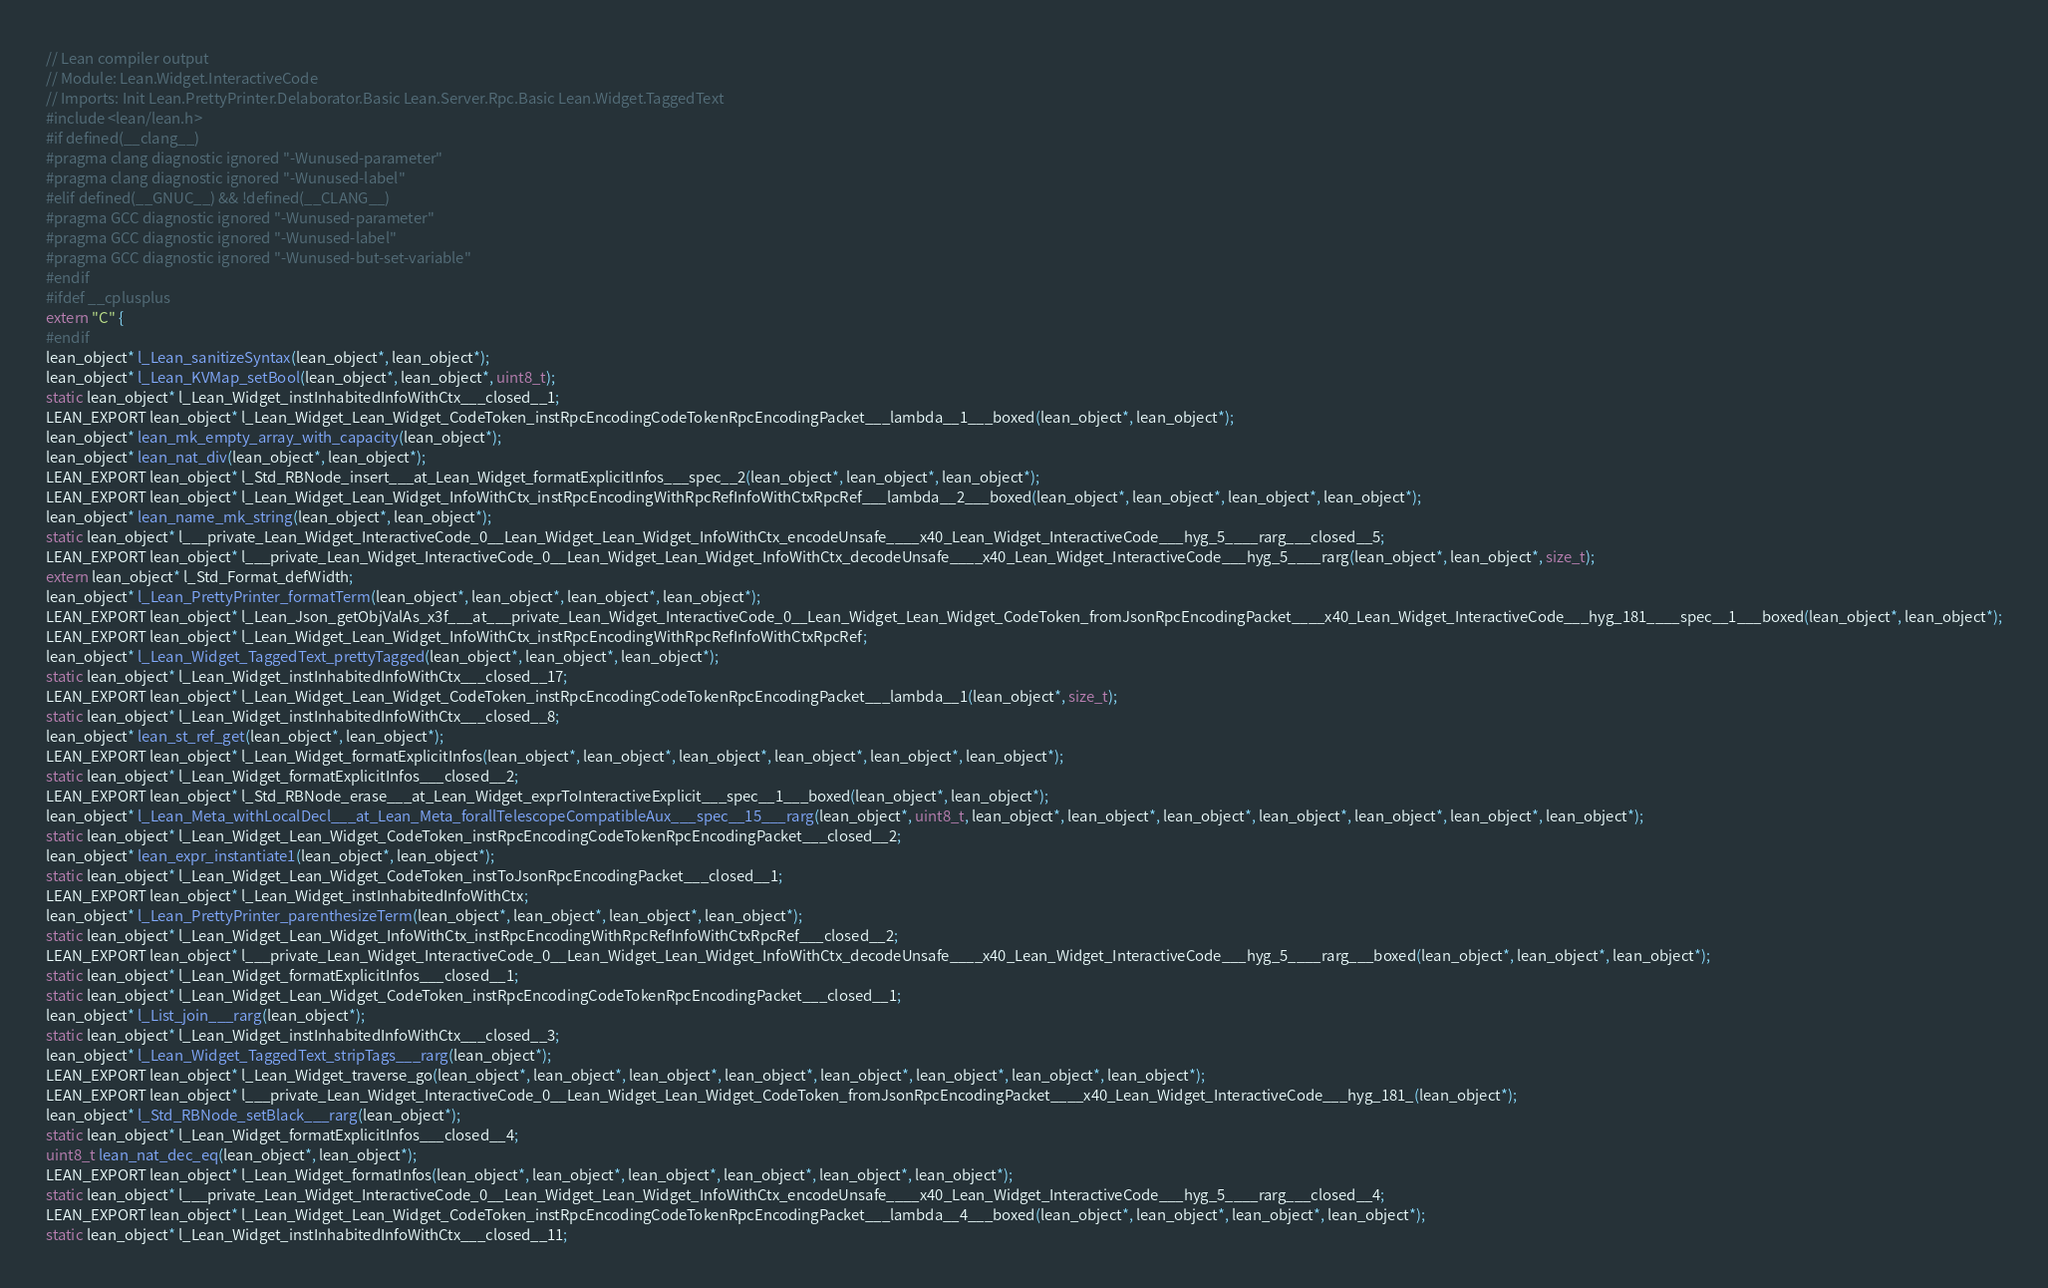Convert code to text. <code><loc_0><loc_0><loc_500><loc_500><_C_>// Lean compiler output
// Module: Lean.Widget.InteractiveCode
// Imports: Init Lean.PrettyPrinter.Delaborator.Basic Lean.Server.Rpc.Basic Lean.Widget.TaggedText
#include <lean/lean.h>
#if defined(__clang__)
#pragma clang diagnostic ignored "-Wunused-parameter"
#pragma clang diagnostic ignored "-Wunused-label"
#elif defined(__GNUC__) && !defined(__CLANG__)
#pragma GCC diagnostic ignored "-Wunused-parameter"
#pragma GCC diagnostic ignored "-Wunused-label"
#pragma GCC diagnostic ignored "-Wunused-but-set-variable"
#endif
#ifdef __cplusplus
extern "C" {
#endif
lean_object* l_Lean_sanitizeSyntax(lean_object*, lean_object*);
lean_object* l_Lean_KVMap_setBool(lean_object*, lean_object*, uint8_t);
static lean_object* l_Lean_Widget_instInhabitedInfoWithCtx___closed__1;
LEAN_EXPORT lean_object* l_Lean_Widget_Lean_Widget_CodeToken_instRpcEncodingCodeTokenRpcEncodingPacket___lambda__1___boxed(lean_object*, lean_object*);
lean_object* lean_mk_empty_array_with_capacity(lean_object*);
lean_object* lean_nat_div(lean_object*, lean_object*);
LEAN_EXPORT lean_object* l_Std_RBNode_insert___at_Lean_Widget_formatExplicitInfos___spec__2(lean_object*, lean_object*, lean_object*);
LEAN_EXPORT lean_object* l_Lean_Widget_Lean_Widget_InfoWithCtx_instRpcEncodingWithRpcRefInfoWithCtxRpcRef___lambda__2___boxed(lean_object*, lean_object*, lean_object*, lean_object*);
lean_object* lean_name_mk_string(lean_object*, lean_object*);
static lean_object* l___private_Lean_Widget_InteractiveCode_0__Lean_Widget_Lean_Widget_InfoWithCtx_encodeUnsafe____x40_Lean_Widget_InteractiveCode___hyg_5____rarg___closed__5;
LEAN_EXPORT lean_object* l___private_Lean_Widget_InteractiveCode_0__Lean_Widget_Lean_Widget_InfoWithCtx_decodeUnsafe____x40_Lean_Widget_InteractiveCode___hyg_5____rarg(lean_object*, lean_object*, size_t);
extern lean_object* l_Std_Format_defWidth;
lean_object* l_Lean_PrettyPrinter_formatTerm(lean_object*, lean_object*, lean_object*, lean_object*);
LEAN_EXPORT lean_object* l_Lean_Json_getObjValAs_x3f___at___private_Lean_Widget_InteractiveCode_0__Lean_Widget_Lean_Widget_CodeToken_fromJsonRpcEncodingPacket____x40_Lean_Widget_InteractiveCode___hyg_181____spec__1___boxed(lean_object*, lean_object*);
LEAN_EXPORT lean_object* l_Lean_Widget_Lean_Widget_InfoWithCtx_instRpcEncodingWithRpcRefInfoWithCtxRpcRef;
lean_object* l_Lean_Widget_TaggedText_prettyTagged(lean_object*, lean_object*, lean_object*);
static lean_object* l_Lean_Widget_instInhabitedInfoWithCtx___closed__17;
LEAN_EXPORT lean_object* l_Lean_Widget_Lean_Widget_CodeToken_instRpcEncodingCodeTokenRpcEncodingPacket___lambda__1(lean_object*, size_t);
static lean_object* l_Lean_Widget_instInhabitedInfoWithCtx___closed__8;
lean_object* lean_st_ref_get(lean_object*, lean_object*);
LEAN_EXPORT lean_object* l_Lean_Widget_formatExplicitInfos(lean_object*, lean_object*, lean_object*, lean_object*, lean_object*, lean_object*);
static lean_object* l_Lean_Widget_formatExplicitInfos___closed__2;
LEAN_EXPORT lean_object* l_Std_RBNode_erase___at_Lean_Widget_exprToInteractiveExplicit___spec__1___boxed(lean_object*, lean_object*);
lean_object* l_Lean_Meta_withLocalDecl___at_Lean_Meta_forallTelescopeCompatibleAux___spec__15___rarg(lean_object*, uint8_t, lean_object*, lean_object*, lean_object*, lean_object*, lean_object*, lean_object*, lean_object*);
static lean_object* l_Lean_Widget_Lean_Widget_CodeToken_instRpcEncodingCodeTokenRpcEncodingPacket___closed__2;
lean_object* lean_expr_instantiate1(lean_object*, lean_object*);
static lean_object* l_Lean_Widget_Lean_Widget_CodeToken_instToJsonRpcEncodingPacket___closed__1;
LEAN_EXPORT lean_object* l_Lean_Widget_instInhabitedInfoWithCtx;
lean_object* l_Lean_PrettyPrinter_parenthesizeTerm(lean_object*, lean_object*, lean_object*, lean_object*);
static lean_object* l_Lean_Widget_Lean_Widget_InfoWithCtx_instRpcEncodingWithRpcRefInfoWithCtxRpcRef___closed__2;
LEAN_EXPORT lean_object* l___private_Lean_Widget_InteractiveCode_0__Lean_Widget_Lean_Widget_InfoWithCtx_decodeUnsafe____x40_Lean_Widget_InteractiveCode___hyg_5____rarg___boxed(lean_object*, lean_object*, lean_object*);
static lean_object* l_Lean_Widget_formatExplicitInfos___closed__1;
static lean_object* l_Lean_Widget_Lean_Widget_CodeToken_instRpcEncodingCodeTokenRpcEncodingPacket___closed__1;
lean_object* l_List_join___rarg(lean_object*);
static lean_object* l_Lean_Widget_instInhabitedInfoWithCtx___closed__3;
lean_object* l_Lean_Widget_TaggedText_stripTags___rarg(lean_object*);
LEAN_EXPORT lean_object* l_Lean_Widget_traverse_go(lean_object*, lean_object*, lean_object*, lean_object*, lean_object*, lean_object*, lean_object*, lean_object*);
LEAN_EXPORT lean_object* l___private_Lean_Widget_InteractiveCode_0__Lean_Widget_Lean_Widget_CodeToken_fromJsonRpcEncodingPacket____x40_Lean_Widget_InteractiveCode___hyg_181_(lean_object*);
lean_object* l_Std_RBNode_setBlack___rarg(lean_object*);
static lean_object* l_Lean_Widget_formatExplicitInfos___closed__4;
uint8_t lean_nat_dec_eq(lean_object*, lean_object*);
LEAN_EXPORT lean_object* l_Lean_Widget_formatInfos(lean_object*, lean_object*, lean_object*, lean_object*, lean_object*, lean_object*);
static lean_object* l___private_Lean_Widget_InteractiveCode_0__Lean_Widget_Lean_Widget_InfoWithCtx_encodeUnsafe____x40_Lean_Widget_InteractiveCode___hyg_5____rarg___closed__4;
LEAN_EXPORT lean_object* l_Lean_Widget_Lean_Widget_CodeToken_instRpcEncodingCodeTokenRpcEncodingPacket___lambda__4___boxed(lean_object*, lean_object*, lean_object*, lean_object*);
static lean_object* l_Lean_Widget_instInhabitedInfoWithCtx___closed__11;</code> 